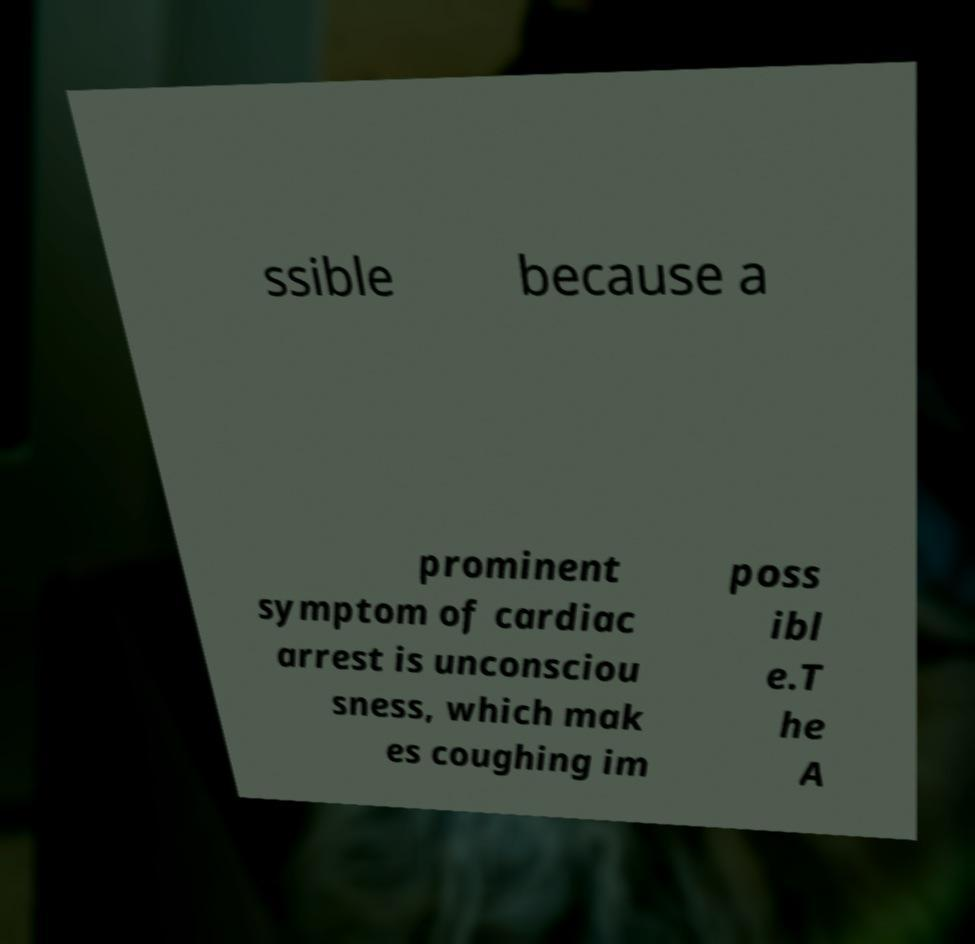Please read and relay the text visible in this image. What does it say? ssible because a prominent symptom of cardiac arrest is unconsciou sness, which mak es coughing im poss ibl e.T he A 